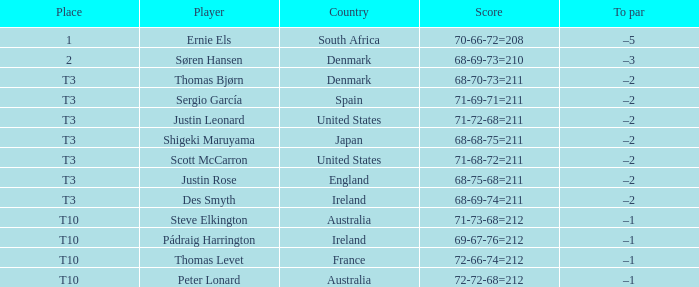What was the score for Peter Lonard? 72-72-68=212. 